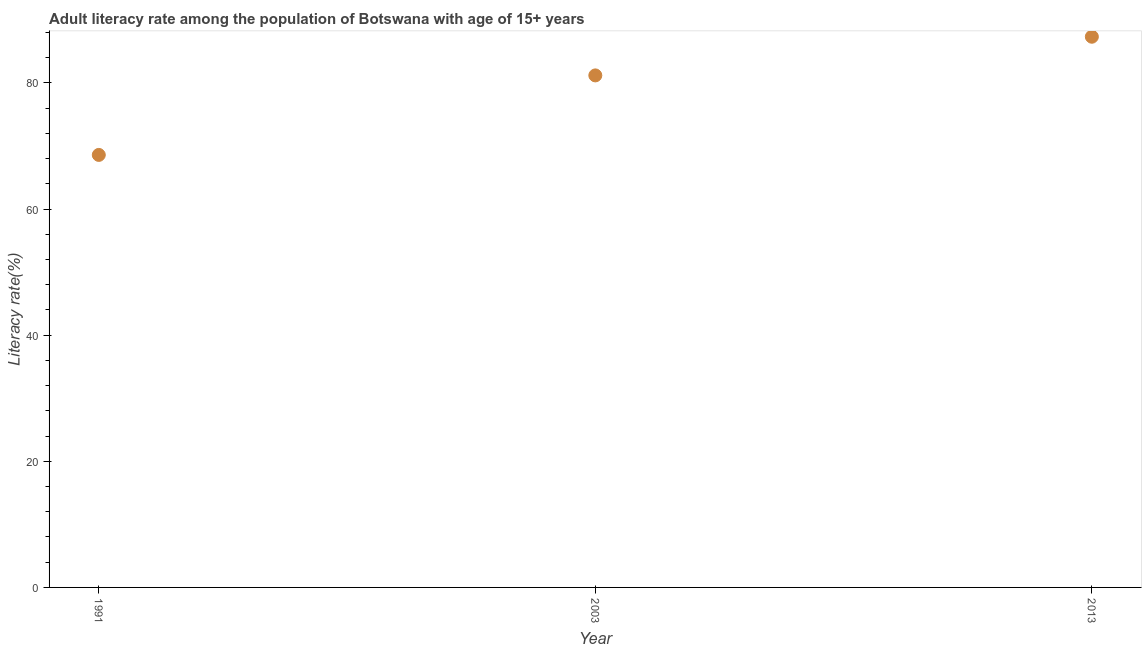What is the adult literacy rate in 1991?
Your answer should be compact. 68.58. Across all years, what is the maximum adult literacy rate?
Provide a succinct answer. 87.32. Across all years, what is the minimum adult literacy rate?
Offer a very short reply. 68.58. In which year was the adult literacy rate maximum?
Keep it short and to the point. 2013. In which year was the adult literacy rate minimum?
Your answer should be very brief. 1991. What is the sum of the adult literacy rate?
Ensure brevity in your answer.  237.09. What is the difference between the adult literacy rate in 1991 and 2013?
Make the answer very short. -18.74. What is the average adult literacy rate per year?
Give a very brief answer. 79.03. What is the median adult literacy rate?
Make the answer very short. 81.19. What is the ratio of the adult literacy rate in 2003 to that in 2013?
Keep it short and to the point. 0.93. What is the difference between the highest and the second highest adult literacy rate?
Your answer should be very brief. 6.13. Is the sum of the adult literacy rate in 1991 and 2003 greater than the maximum adult literacy rate across all years?
Provide a succinct answer. Yes. What is the difference between the highest and the lowest adult literacy rate?
Provide a succinct answer. 18.74. In how many years, is the adult literacy rate greater than the average adult literacy rate taken over all years?
Your response must be concise. 2. Does the adult literacy rate monotonically increase over the years?
Offer a very short reply. Yes. How many dotlines are there?
Ensure brevity in your answer.  1. Are the values on the major ticks of Y-axis written in scientific E-notation?
Your answer should be very brief. No. Does the graph contain any zero values?
Provide a short and direct response. No. Does the graph contain grids?
Offer a very short reply. No. What is the title of the graph?
Make the answer very short. Adult literacy rate among the population of Botswana with age of 15+ years. What is the label or title of the Y-axis?
Provide a short and direct response. Literacy rate(%). What is the Literacy rate(%) in 1991?
Your response must be concise. 68.58. What is the Literacy rate(%) in 2003?
Keep it short and to the point. 81.19. What is the Literacy rate(%) in 2013?
Offer a very short reply. 87.32. What is the difference between the Literacy rate(%) in 1991 and 2003?
Give a very brief answer. -12.61. What is the difference between the Literacy rate(%) in 1991 and 2013?
Offer a terse response. -18.74. What is the difference between the Literacy rate(%) in 2003 and 2013?
Keep it short and to the point. -6.13. What is the ratio of the Literacy rate(%) in 1991 to that in 2003?
Your answer should be compact. 0.84. What is the ratio of the Literacy rate(%) in 1991 to that in 2013?
Your response must be concise. 0.79. What is the ratio of the Literacy rate(%) in 2003 to that in 2013?
Give a very brief answer. 0.93. 